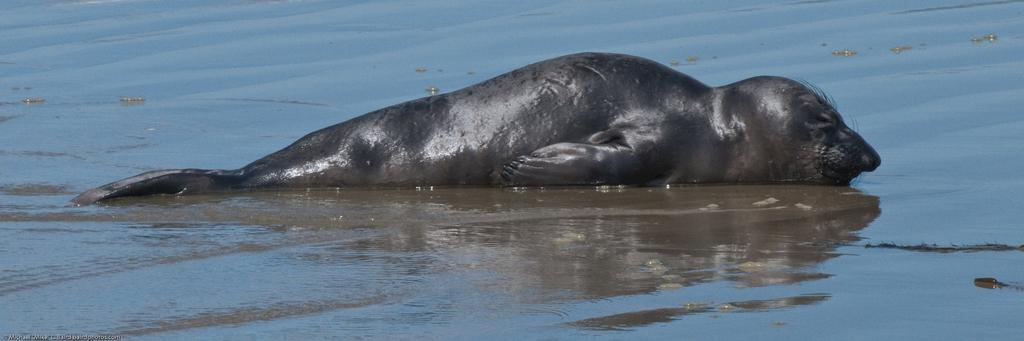What type of surface can be seen in the image? There is ground visible in the image. What is present on the ground in the image? There is water on the ground in the image. What kind of creature is in the water in the image? There is an aquatic animal in the image. What color is the aquatic animal in the image? The aquatic animal is black in color. How many feet does the aquatic animal have in the image? Aquatic animals, such as fish, typically do not have feet. The black aquatic animal in the image does not have feet. 